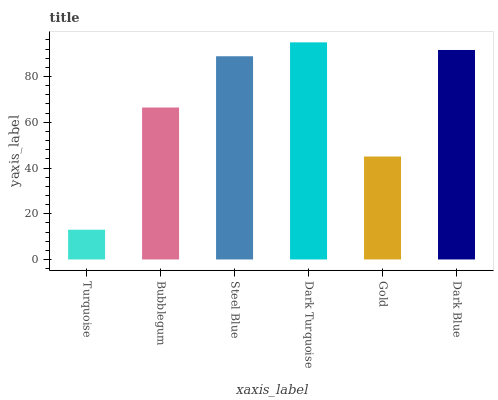Is Turquoise the minimum?
Answer yes or no. Yes. Is Dark Turquoise the maximum?
Answer yes or no. Yes. Is Bubblegum the minimum?
Answer yes or no. No. Is Bubblegum the maximum?
Answer yes or no. No. Is Bubblegum greater than Turquoise?
Answer yes or no. Yes. Is Turquoise less than Bubblegum?
Answer yes or no. Yes. Is Turquoise greater than Bubblegum?
Answer yes or no. No. Is Bubblegum less than Turquoise?
Answer yes or no. No. Is Steel Blue the high median?
Answer yes or no. Yes. Is Bubblegum the low median?
Answer yes or no. Yes. Is Dark Turquoise the high median?
Answer yes or no. No. Is Dark Turquoise the low median?
Answer yes or no. No. 